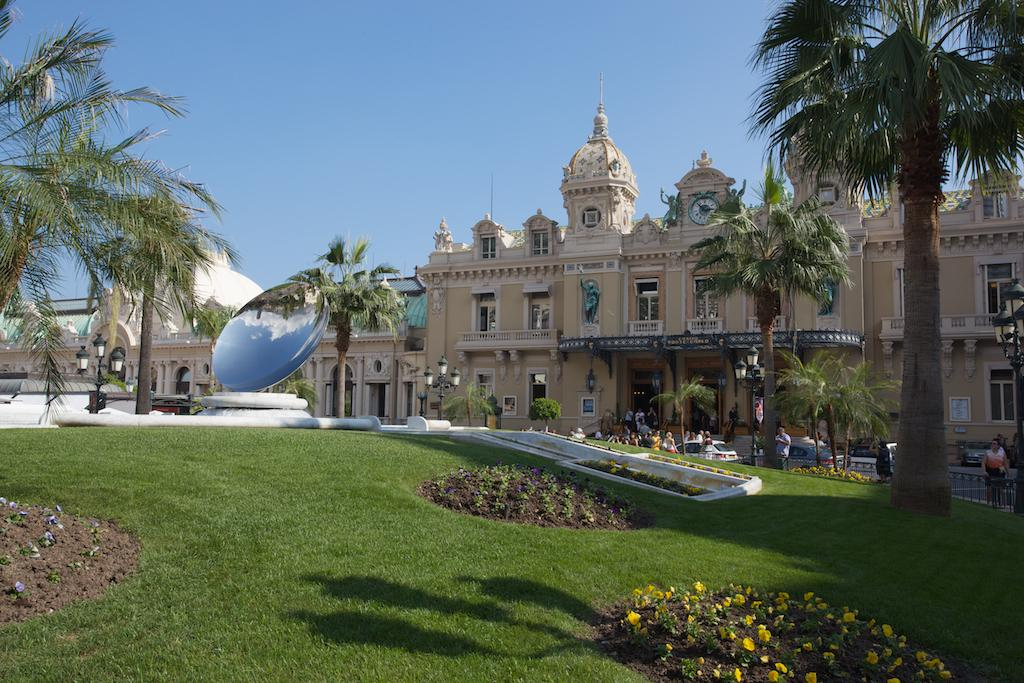What type of vegetation is present on the ground in the image? There is grass on the ground in the image. What other natural elements can be seen in the image? There are flowers in the image. What can be seen in the background of the image? There are buildings, trees, persons, and poles in the background of the image. What type of cow can be seen interacting with the persons in the image? There is no cow present in the image; it only features grass, flowers, buildings, trees, persons, and poles. What idea is being discussed by the persons in the image? There is no indication of a discussion or idea being presented in the image, as it only shows the background elements and the persons in the background. 